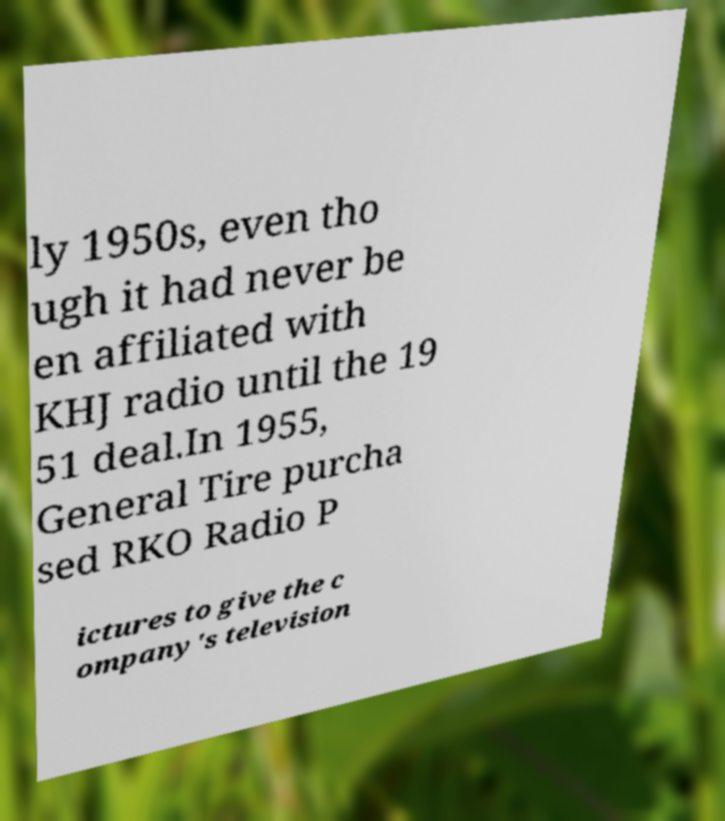I need the written content from this picture converted into text. Can you do that? ly 1950s, even tho ugh it had never be en affiliated with KHJ radio until the 19 51 deal.In 1955, General Tire purcha sed RKO Radio P ictures to give the c ompany's television 